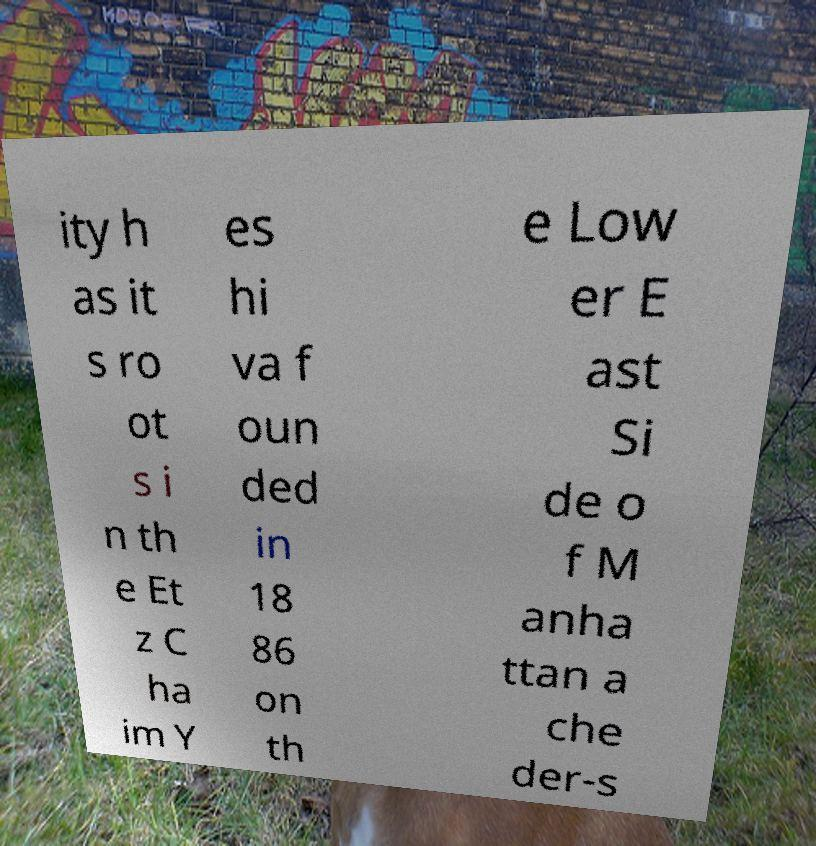There's text embedded in this image that I need extracted. Can you transcribe it verbatim? ity h as it s ro ot s i n th e Et z C ha im Y es hi va f oun ded in 18 86 on th e Low er E ast Si de o f M anha ttan a che der-s 